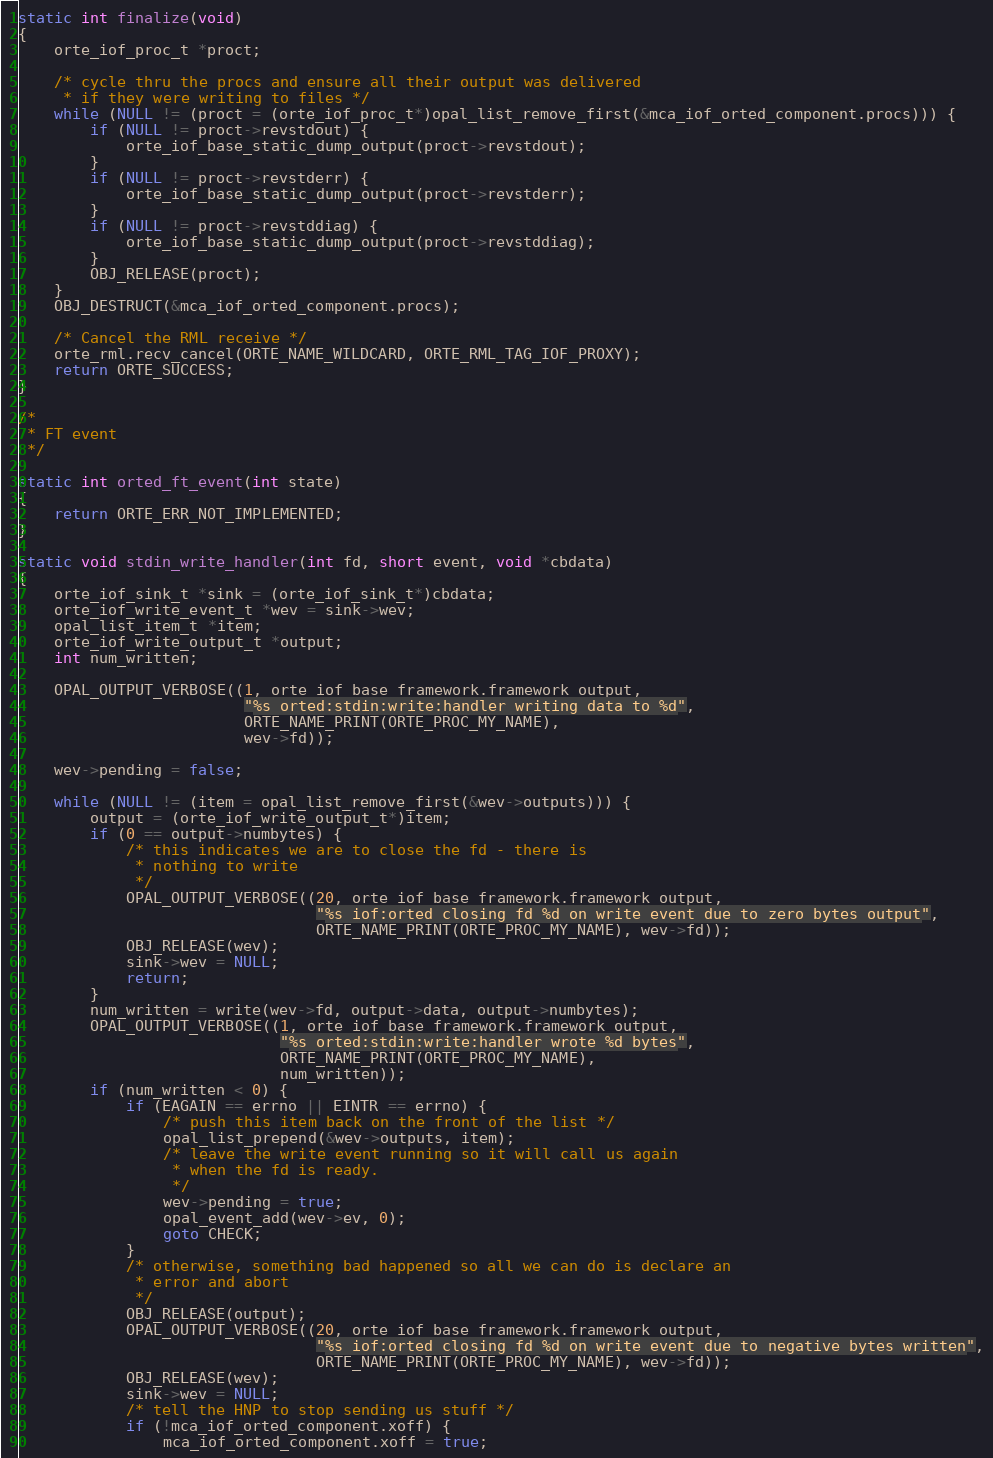<code> <loc_0><loc_0><loc_500><loc_500><_C_>static int finalize(void)
{
    orte_iof_proc_t *proct;

    /* cycle thru the procs and ensure all their output was delivered
     * if they were writing to files */
    while (NULL != (proct = (orte_iof_proc_t*)opal_list_remove_first(&mca_iof_orted_component.procs))) {
        if (NULL != proct->revstdout) {
            orte_iof_base_static_dump_output(proct->revstdout);
        }
        if (NULL != proct->revstderr) {
            orte_iof_base_static_dump_output(proct->revstderr);
        }
        if (NULL != proct->revstddiag) {
            orte_iof_base_static_dump_output(proct->revstddiag);
        }
        OBJ_RELEASE(proct);
    }
    OBJ_DESTRUCT(&mca_iof_orted_component.procs);

    /* Cancel the RML receive */
    orte_rml.recv_cancel(ORTE_NAME_WILDCARD, ORTE_RML_TAG_IOF_PROXY);
    return ORTE_SUCCESS;
}

/*
 * FT event
 */

static int orted_ft_event(int state)
{
    return ORTE_ERR_NOT_IMPLEMENTED;
}

static void stdin_write_handler(int fd, short event, void *cbdata)
{
    orte_iof_sink_t *sink = (orte_iof_sink_t*)cbdata;
    orte_iof_write_event_t *wev = sink->wev;
    opal_list_item_t *item;
    orte_iof_write_output_t *output;
    int num_written;

    OPAL_OUTPUT_VERBOSE((1, orte_iof_base_framework.framework_output,
                         "%s orted:stdin:write:handler writing data to %d",
                         ORTE_NAME_PRINT(ORTE_PROC_MY_NAME),
                         wev->fd));

    wev->pending = false;

    while (NULL != (item = opal_list_remove_first(&wev->outputs))) {
        output = (orte_iof_write_output_t*)item;
        if (0 == output->numbytes) {
            /* this indicates we are to close the fd - there is
             * nothing to write
             */
            OPAL_OUTPUT_VERBOSE((20, orte_iof_base_framework.framework_output,
                                 "%s iof:orted closing fd %d on write event due to zero bytes output",
                                 ORTE_NAME_PRINT(ORTE_PROC_MY_NAME), wev->fd));
            OBJ_RELEASE(wev);
            sink->wev = NULL;
            return;
        }
        num_written = write(wev->fd, output->data, output->numbytes);
        OPAL_OUTPUT_VERBOSE((1, orte_iof_base_framework.framework_output,
                             "%s orted:stdin:write:handler wrote %d bytes",
                             ORTE_NAME_PRINT(ORTE_PROC_MY_NAME),
                             num_written));
        if (num_written < 0) {
            if (EAGAIN == errno || EINTR == errno) {
                /* push this item back on the front of the list */
                opal_list_prepend(&wev->outputs, item);
                /* leave the write event running so it will call us again
                 * when the fd is ready.
                 */
                wev->pending = true;
                opal_event_add(wev->ev, 0);
                goto CHECK;
            }
            /* otherwise, something bad happened so all we can do is declare an
             * error and abort
             */
            OBJ_RELEASE(output);
            OPAL_OUTPUT_VERBOSE((20, orte_iof_base_framework.framework_output,
                                 "%s iof:orted closing fd %d on write event due to negative bytes written",
                                 ORTE_NAME_PRINT(ORTE_PROC_MY_NAME), wev->fd));
            OBJ_RELEASE(wev);
            sink->wev = NULL;
            /* tell the HNP to stop sending us stuff */
            if (!mca_iof_orted_component.xoff) {
                mca_iof_orted_component.xoff = true;</code> 